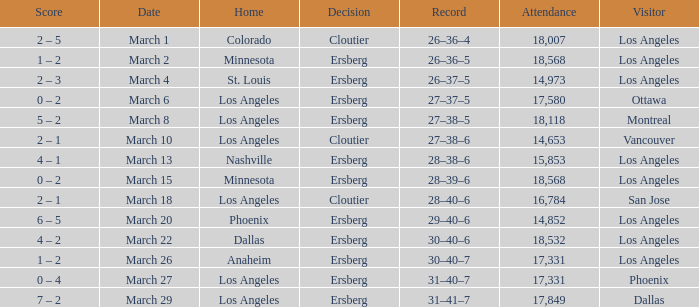On the Date of March 13, who was the Home team? Nashville. 